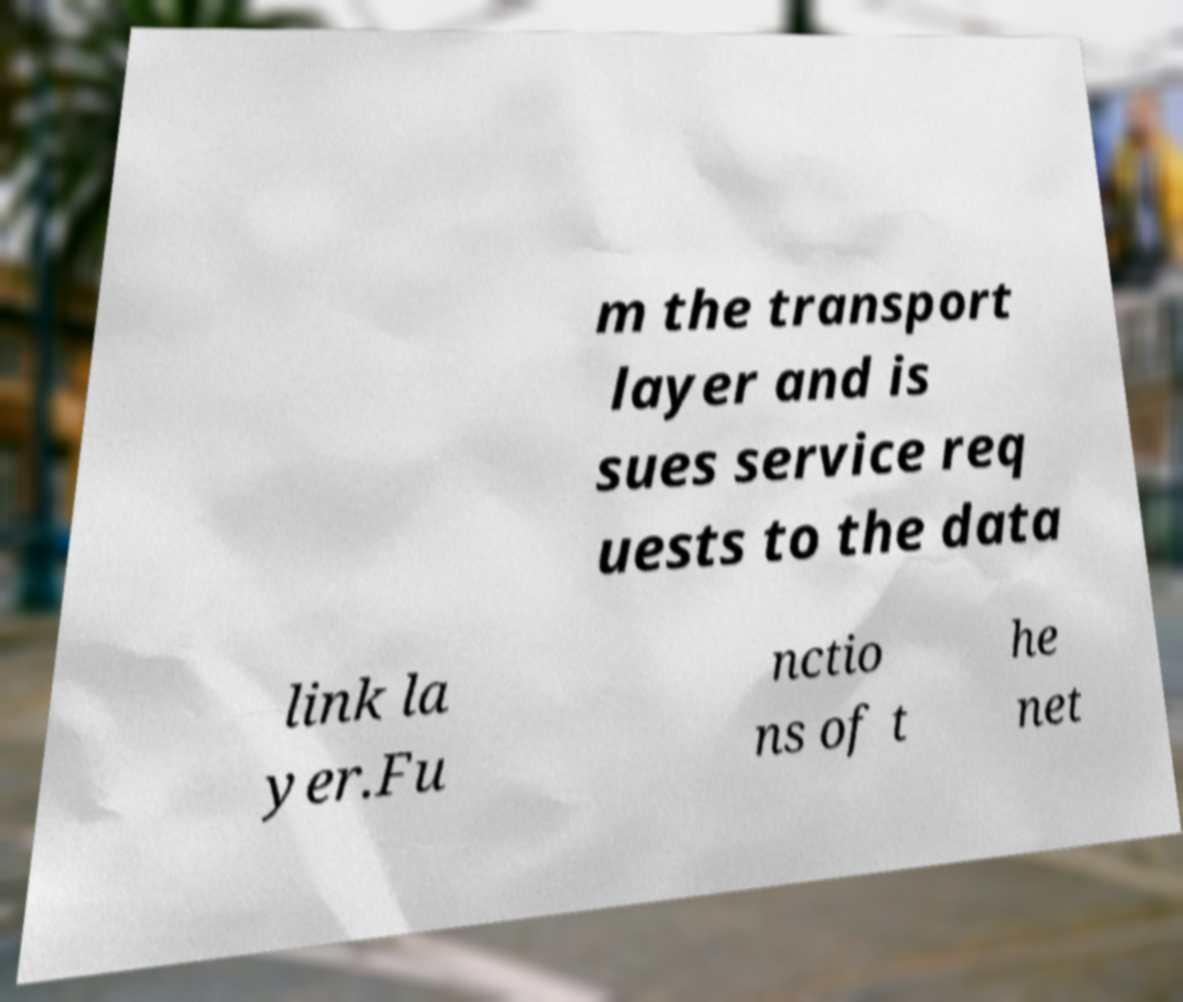There's text embedded in this image that I need extracted. Can you transcribe it verbatim? m the transport layer and is sues service req uests to the data link la yer.Fu nctio ns of t he net 